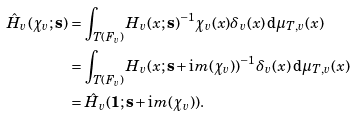<formula> <loc_0><loc_0><loc_500><loc_500>\hat { H } _ { v } ( \chi _ { v } ; \mathbf s ) & = \int _ { T ( F _ { v } ) } H _ { v } ( x ; \mathbf s ) ^ { - 1 } \chi _ { v } ( x ) \delta _ { v } ( x ) \, \mathrm d \mu _ { T , v } ( x ) \\ & = \int _ { T ( F _ { v } ) } H _ { v } ( x ; \mathbf s + \mathrm i m ( \chi _ { v } ) ) ^ { - 1 } \delta _ { v } ( x ) \, \mathrm d \mu _ { T , v } ( x ) \\ & = \hat { H } _ { v } ( \mathbf 1 ; \mathbf s + \mathrm i m ( \chi _ { v } ) ) .</formula> 